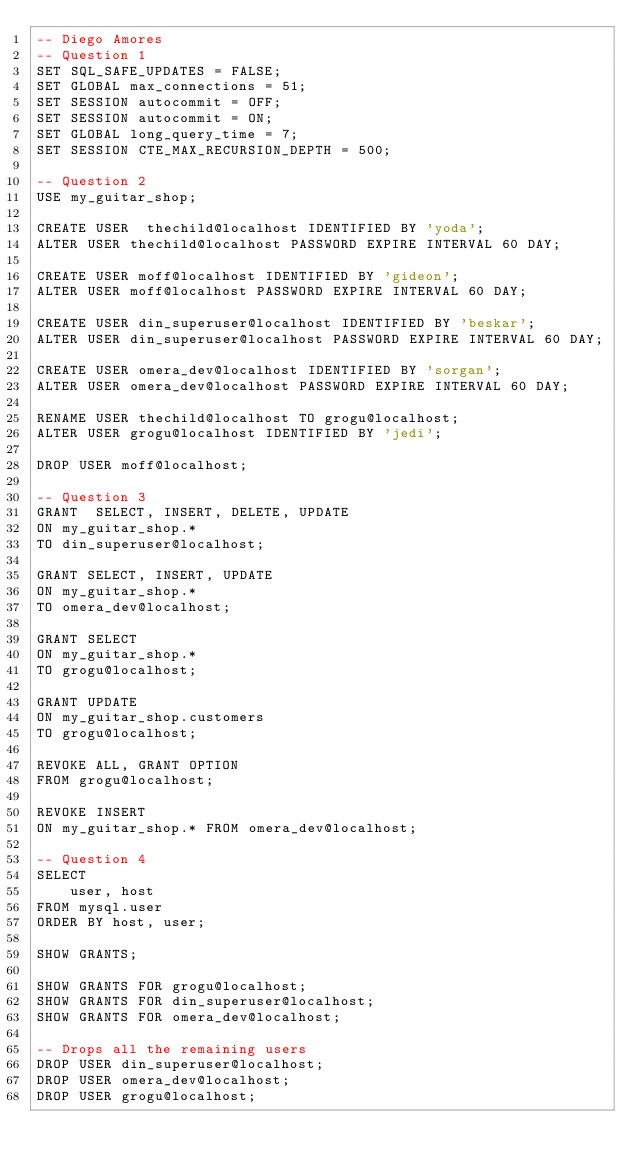Convert code to text. <code><loc_0><loc_0><loc_500><loc_500><_SQL_>-- Diego Amores
-- Question 1
SET SQL_SAFE_UPDATES = FALSE;
SET GLOBAL max_connections = 51;
SET SESSION autocommit = OFF;
SET SESSION autocommit = ON;
SET GLOBAL long_query_time = 7;
SET SESSION CTE_MAX_RECURSION_DEPTH = 500;

-- Question 2
USE my_guitar_shop;

CREATE USER  thechild@localhost IDENTIFIED BY 'yoda';
ALTER USER thechild@localhost PASSWORD EXPIRE INTERVAL 60 DAY;

CREATE USER moff@localhost IDENTIFIED BY 'gideon';
ALTER USER moff@localhost PASSWORD EXPIRE INTERVAL 60 DAY;

CREATE USER din_superuser@localhost IDENTIFIED BY 'beskar';
ALTER USER din_superuser@localhost PASSWORD EXPIRE INTERVAL 60 DAY;

CREATE USER omera_dev@localhost IDENTIFIED BY 'sorgan';
ALTER USER omera_dev@localhost PASSWORD EXPIRE INTERVAL 60 DAY;

RENAME USER thechild@localhost TO grogu@localhost;
ALTER USER grogu@localhost IDENTIFIED BY 'jedi';

DROP USER moff@localhost;

-- Question 3
GRANT  SELECT, INSERT, DELETE, UPDATE
ON my_guitar_shop.*
TO din_superuser@localhost;

GRANT SELECT, INSERT, UPDATE
ON my_guitar_shop.*
TO omera_dev@localhost;

GRANT SELECT
ON my_guitar_shop.*
TO grogu@localhost;

GRANT UPDATE
ON my_guitar_shop.customers
TO grogu@localhost;

REVOKE ALL, GRANT OPTION
FROM grogu@localhost;

REVOKE INSERT
ON my_guitar_shop.* FROM omera_dev@localhost;

-- Question 4
SELECT
	user, host
FROM mysql.user
ORDER BY host, user;

SHOW GRANTS;

SHOW GRANTS FOR grogu@localhost;
SHOW GRANTS FOR din_superuser@localhost;
SHOW GRANTS FOR omera_dev@localhost;

-- Drops all the remaining users
DROP USER din_superuser@localhost;
DROP USER omera_dev@localhost;
DROP USER grogu@localhost;</code> 